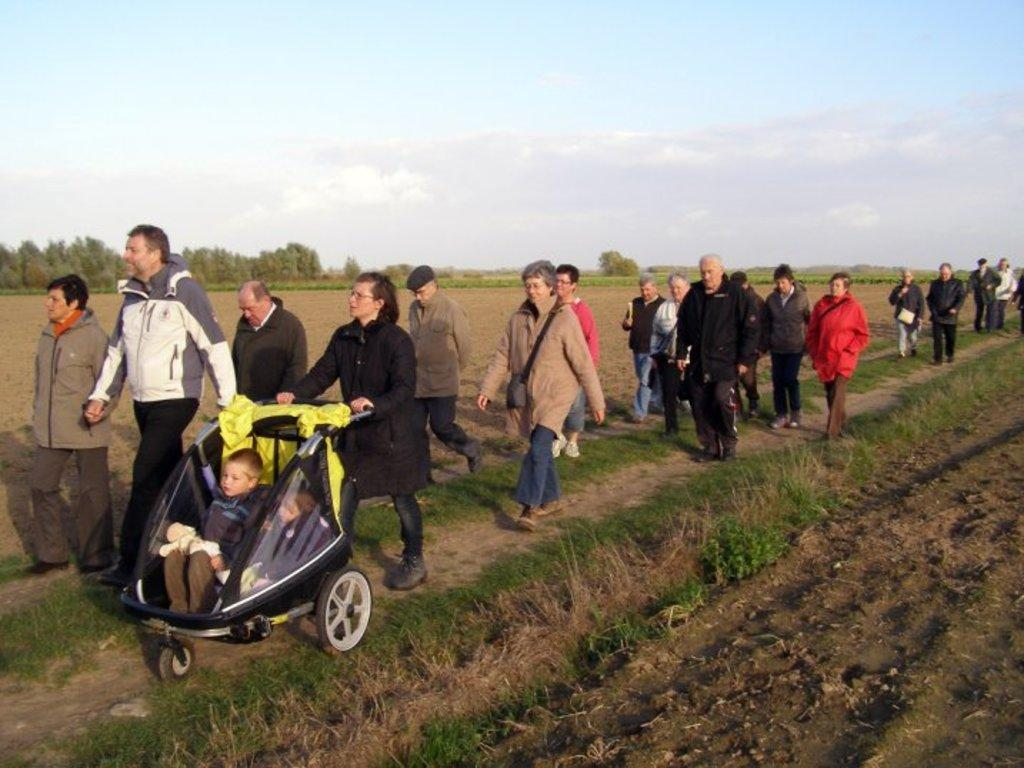Who or what can be seen in the image? There are people in the image. What type of terrain is visible in the image? The ground with grass is visible in the image. What other natural elements can be seen in the image? There are trees and plants in the image. What is visible in the background of the image? The sky is visible in the image, and clouds are present in the sky. What type of protest is taking place in the image? There is no protest present in the image; it features people, grass, trees, plants, and the sky. How many copies of the edge can be seen in the image? There is no edge present in the image, so it is not possible to determine the number of copies. 